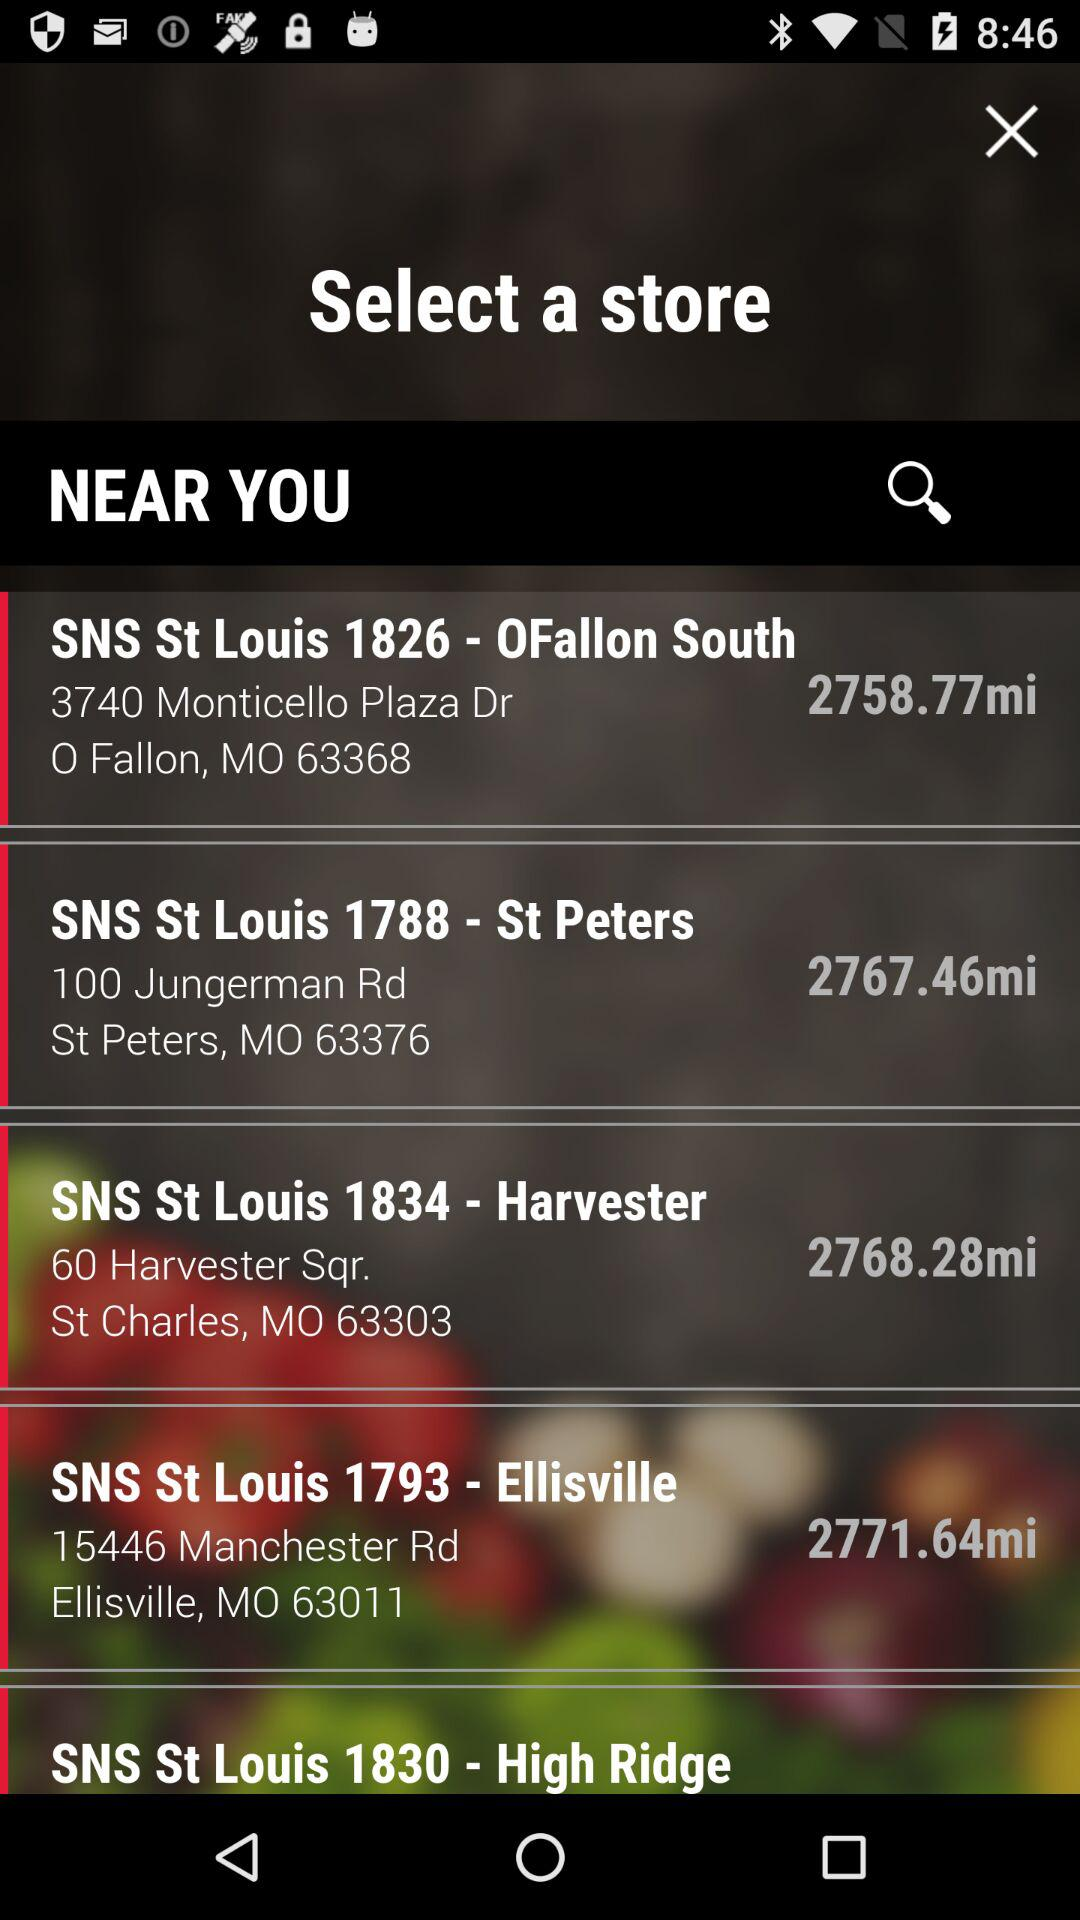Which is the farthest store?
When the provided information is insufficient, respond with <no answer>. <no answer> 